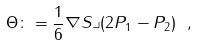Convert formula to latex. <formula><loc_0><loc_0><loc_500><loc_500>\Theta \colon = \frac { 1 } { 6 } \nabla S \lrcorner ( 2 P _ { 1 } - P _ { 2 } ) \ ,</formula> 